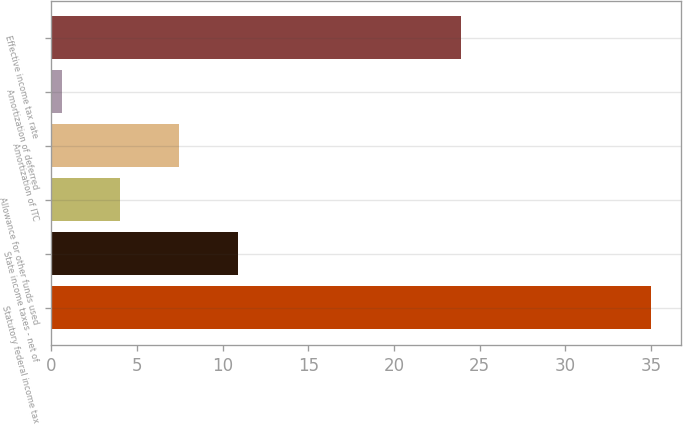Convert chart. <chart><loc_0><loc_0><loc_500><loc_500><bar_chart><fcel>Statutory federal income tax<fcel>State income taxes - net of<fcel>Allowance for other funds used<fcel>Amortization of ITC<fcel>Amortization of deferred<fcel>Effective income tax rate<nl><fcel>35<fcel>10.92<fcel>4.04<fcel>7.48<fcel>0.6<fcel>23.9<nl></chart> 